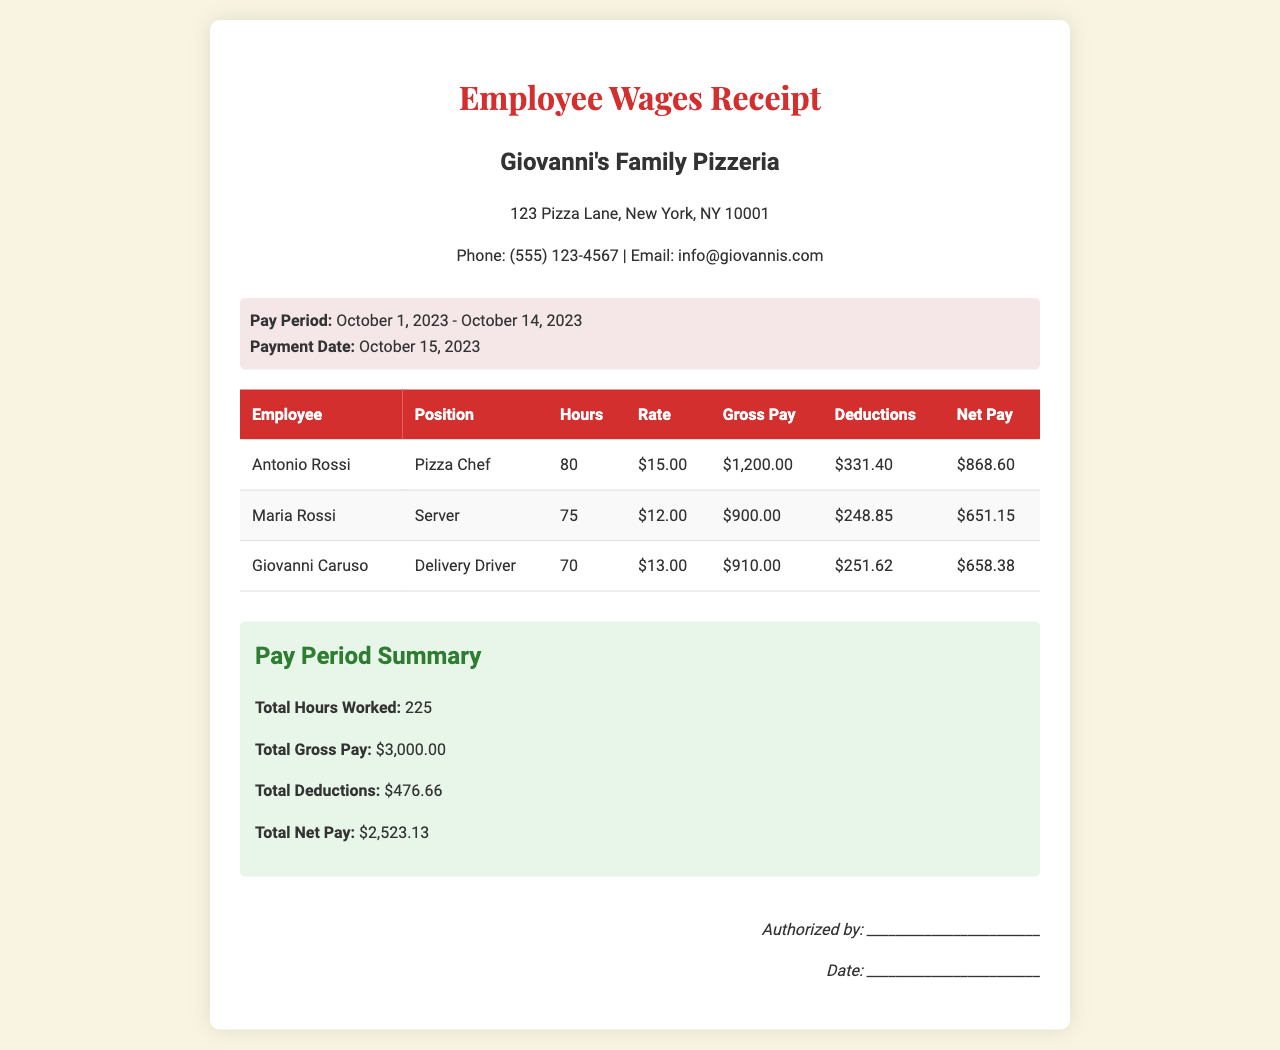What is the pay period? The pay period is specified in the document as the timeframe for which employees are paid, stated as "October 1, 2023 - October 14, 2023."
Answer: October 1, 2023 - October 14, 2023 Who is the Delivery Driver? The document lists employees along with their positions, and Giovanni Caruso is identified as the Delivery Driver.
Answer: Giovanni Caruso How many hours did Maria Rossi work? The document provides the number of hours worked by each employee, with Maria Rossi listed as having worked 75 hours.
Answer: 75 What is the total net pay for all employees? The total net pay is the aggregate of net pays for each employee, which is stated as $2,523.13 in the summary section.
Answer: $2,523.13 What is Antonio Rossi's gross pay? The gross pay for Antonio Rossi is specifically mentioned in the document as $1,200.00.
Answer: $1,200.00 What is the total number of hours worked by all employees? This is the sum of all hours worked, which is provided in the summary as 225 hours.
Answer: 225 What is the deduction amount for Giovanni Caruso? The deductions for Giovanni Caruso are listed in the document as $251.62.
Answer: $251.62 What was the payment date? The payment date is mentioned clearly in the document, which is October 15, 2023.
Answer: October 15, 2023 What is the gross pay for the Server? The gross pay for the Server, listed as Maria Rossi, is $900.00.
Answer: $900.00 